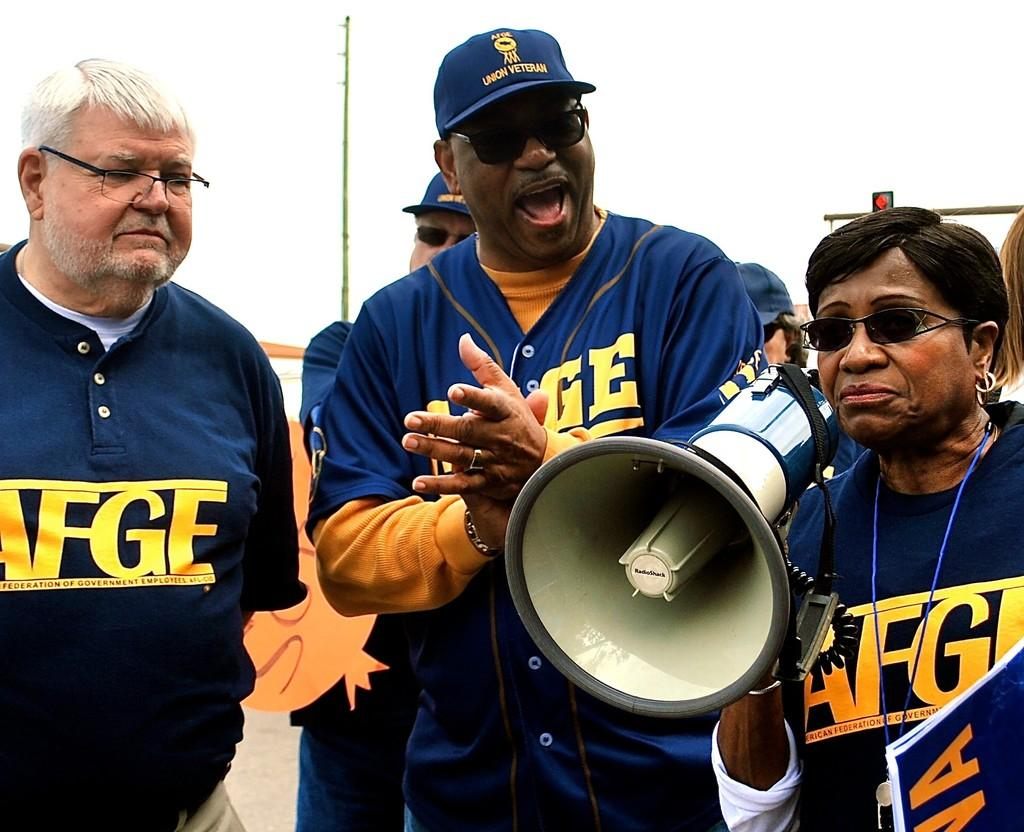<image>
Relay a brief, clear account of the picture shown. a few people in jerseys with FGE on them 